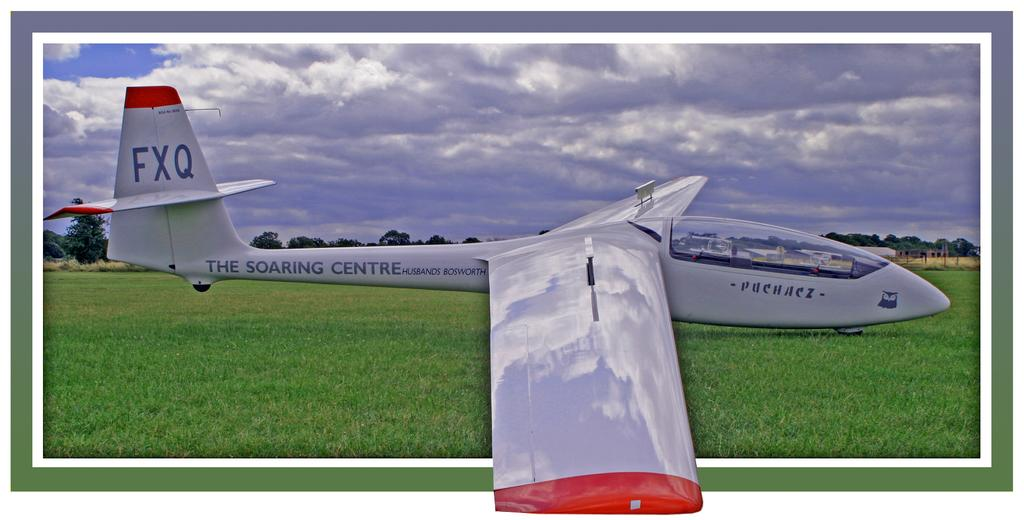<image>
Write a terse but informative summary of the picture. An oddly shaped plane advertises The Soaring Centre on its tail section. 